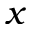<formula> <loc_0><loc_0><loc_500><loc_500>x</formula> 